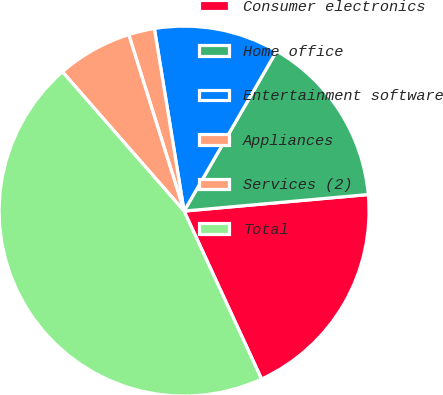Convert chart. <chart><loc_0><loc_0><loc_500><loc_500><pie_chart><fcel>Consumer electronics<fcel>Home office<fcel>Entertainment software<fcel>Appliances<fcel>Services (2)<fcel>Total<nl><fcel>19.55%<fcel>15.23%<fcel>10.91%<fcel>2.27%<fcel>6.59%<fcel>45.45%<nl></chart> 